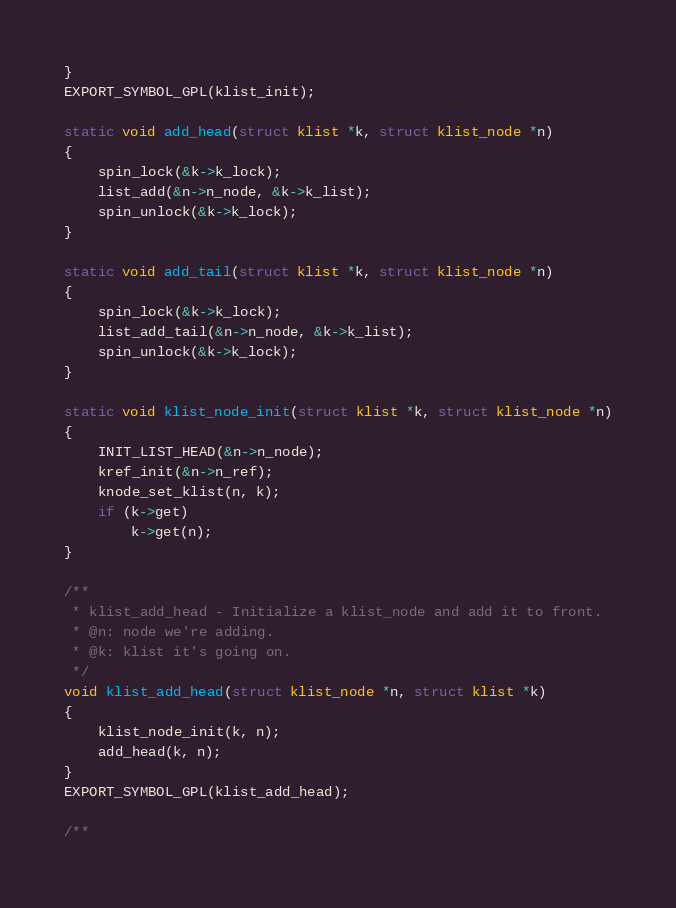Convert code to text. <code><loc_0><loc_0><loc_500><loc_500><_C_>}
EXPORT_SYMBOL_GPL(klist_init);

static void add_head(struct klist *k, struct klist_node *n)
{
	spin_lock(&k->k_lock);
	list_add(&n->n_node, &k->k_list);
	spin_unlock(&k->k_lock);
}

static void add_tail(struct klist *k, struct klist_node *n)
{
	spin_lock(&k->k_lock);
	list_add_tail(&n->n_node, &k->k_list);
	spin_unlock(&k->k_lock);
}

static void klist_node_init(struct klist *k, struct klist_node *n)
{
	INIT_LIST_HEAD(&n->n_node);
	kref_init(&n->n_ref);
	knode_set_klist(n, k);
	if (k->get)
		k->get(n);
}

/**
 * klist_add_head - Initialize a klist_node and add it to front.
 * @n: node we're adding.
 * @k: klist it's going on.
 */
void klist_add_head(struct klist_node *n, struct klist *k)
{
	klist_node_init(k, n);
	add_head(k, n);
}
EXPORT_SYMBOL_GPL(klist_add_head);

/**</code> 